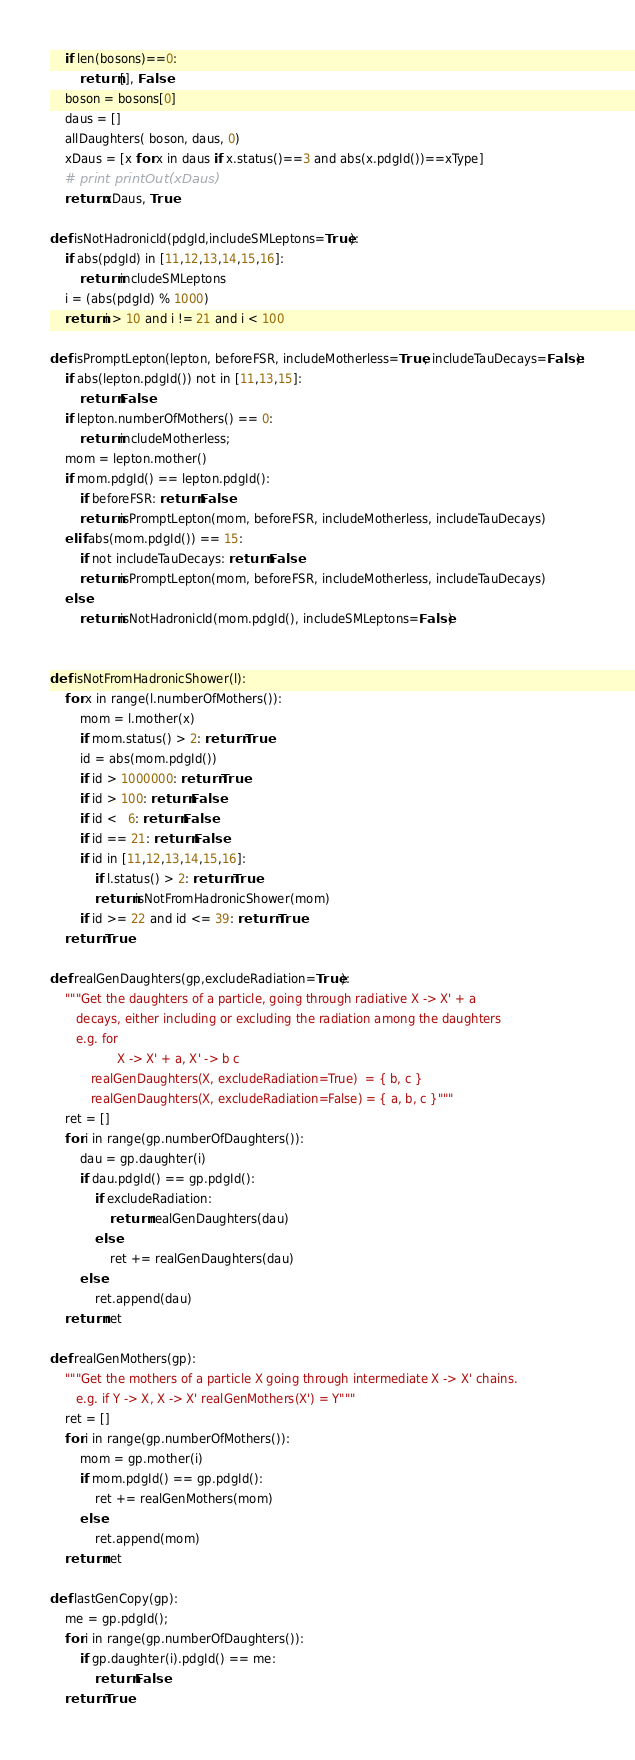<code> <loc_0><loc_0><loc_500><loc_500><_Python_>    if len(bosons)==0:
        return [], False
    boson = bosons[0]
    daus = []
    allDaughters( boson, daus, 0)
    xDaus = [x for x in daus if x.status()==3 and abs(x.pdgId())==xType]
    # print printOut(xDaus)
    return xDaus, True 

def isNotHadronicId(pdgId,includeSMLeptons=True):
    if abs(pdgId) in [11,12,13,14,15,16]:
        return includeSMLeptons
    i = (abs(pdgId) % 1000)
    return i > 10 and i != 21 and i < 100

def isPromptLepton(lepton, beforeFSR, includeMotherless=True, includeTauDecays=False):
    if abs(lepton.pdgId()) not in [11,13,15]:
        return False
    if lepton.numberOfMothers() == 0:
        return includeMotherless;
    mom = lepton.mother()
    if mom.pdgId() == lepton.pdgId():
        if beforeFSR: return False
        return isPromptLepton(mom, beforeFSR, includeMotherless, includeTauDecays)
    elif abs(mom.pdgId()) == 15:
        if not includeTauDecays: return False
        return isPromptLepton(mom, beforeFSR, includeMotherless, includeTauDecays)
    else:
        return isNotHadronicId(mom.pdgId(), includeSMLeptons=False)


def isNotFromHadronicShower(l):
    for x in range(l.numberOfMothers()):
        mom = l.mother(x)
        if mom.status() > 2: return True
        id = abs(mom.pdgId())
        if id > 1000000: return True
        if id > 100: return False
        if id <   6: return False
        if id == 21: return False
        if id in [11,12,13,14,15,16]: 
            if l.status() > 2: return True
            return isNotFromHadronicShower(mom)
        if id >= 22 and id <= 39: return True
    return True

def realGenDaughters(gp,excludeRadiation=True):
    """Get the daughters of a particle, going through radiative X -> X' + a
       decays, either including or excluding the radiation among the daughters
       e.g. for  
                  X -> X' + a, X' -> b c 
           realGenDaughters(X, excludeRadiation=True)  = { b, c }
           realGenDaughters(X, excludeRadiation=False) = { a, b, c }"""
    ret = []
    for i in range(gp.numberOfDaughters()):
        dau = gp.daughter(i)
        if dau.pdgId() == gp.pdgId():
            if excludeRadiation:
                return realGenDaughters(dau)
            else:
                ret += realGenDaughters(dau)
        else:
            ret.append(dau)
    return ret

def realGenMothers(gp):
    """Get the mothers of a particle X going through intermediate X -> X' chains.
       e.g. if Y -> X, X -> X' realGenMothers(X') = Y"""
    ret = []
    for i in range(gp.numberOfMothers()):
        mom = gp.mother(i)
        if mom.pdgId() == gp.pdgId():
            ret += realGenMothers(mom)
        else:
            ret.append(mom)
    return ret

def lastGenCopy(gp):
    me = gp.pdgId();
    for i in range(gp.numberOfDaughters()):
        if gp.daughter(i).pdgId() == me:
            return False
    return True


</code> 